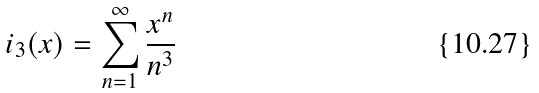<formula> <loc_0><loc_0><loc_500><loc_500>\L i _ { 3 } ( x ) = \sum _ { n = 1 } ^ { \infty } \frac { x ^ { n } } { n ^ { 3 } }</formula> 